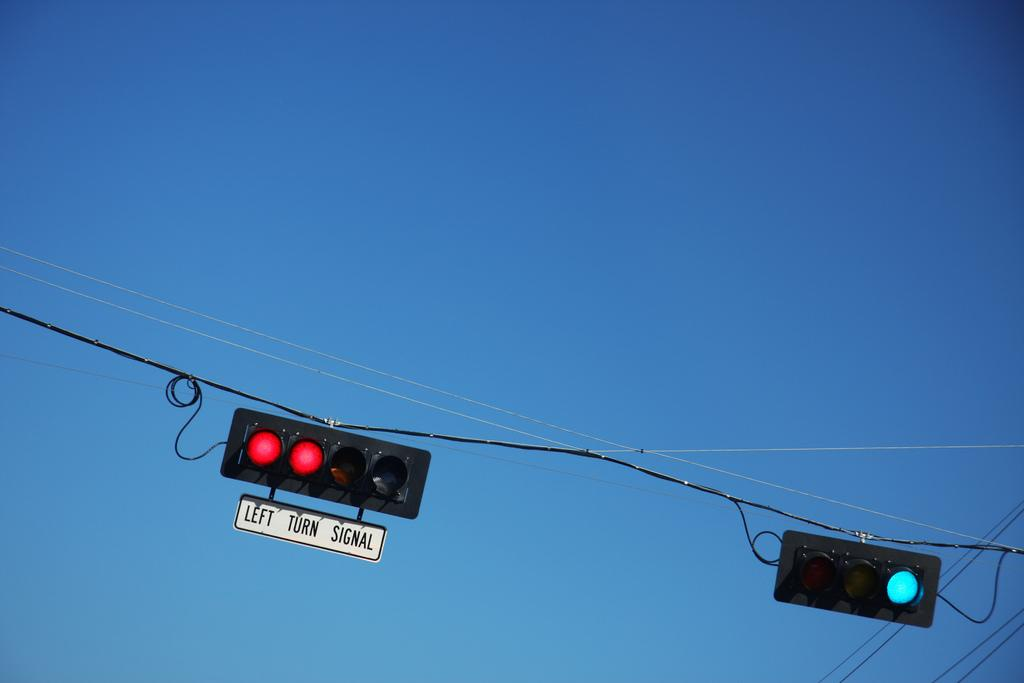<image>
Describe the image concisely. A pair of traffic lights, the one on the left says left turn signal underneath it. 